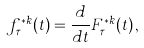<formula> <loc_0><loc_0><loc_500><loc_500>f ^ { * k } _ { \tau } ( t ) = \frac { d } { d t } F ^ { * k } _ { \tau } ( t ) \, ,</formula> 